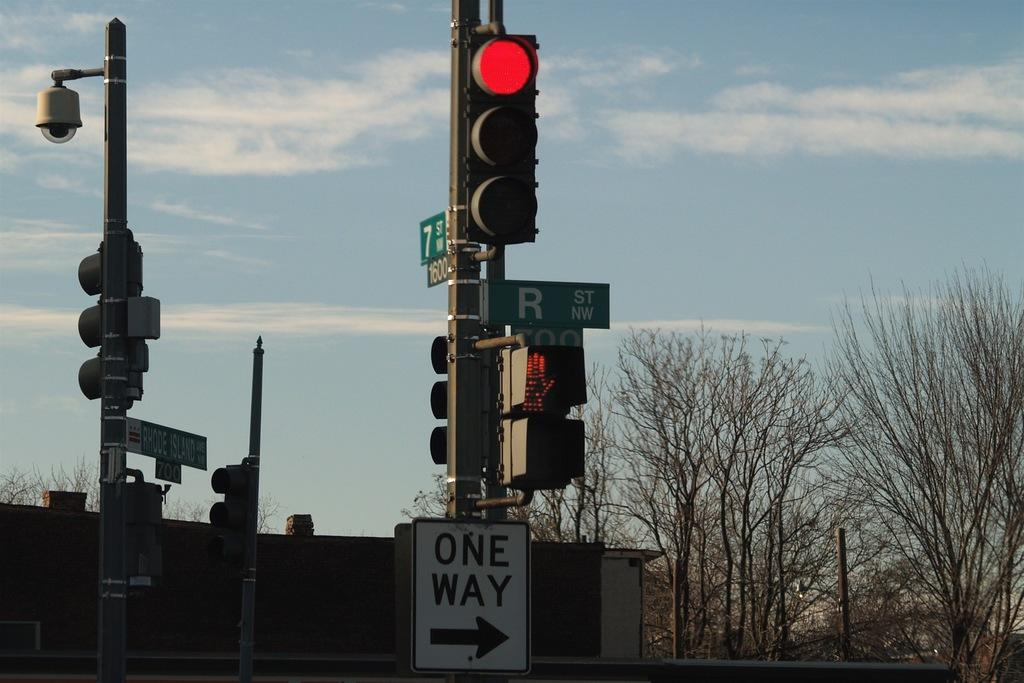Provide a one-sentence caption for the provided image. A street sign name "r" on a post. 